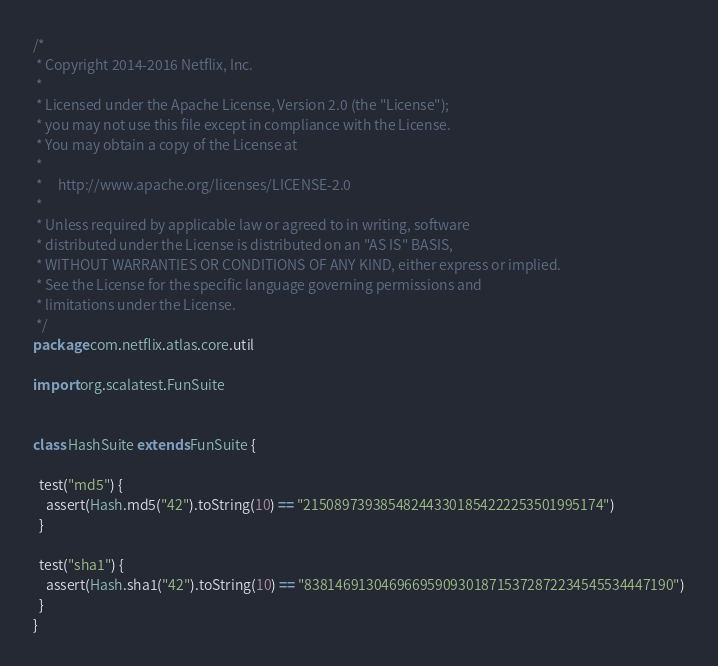<code> <loc_0><loc_0><loc_500><loc_500><_Scala_>/*
 * Copyright 2014-2016 Netflix, Inc.
 *
 * Licensed under the Apache License, Version 2.0 (the "License");
 * you may not use this file except in compliance with the License.
 * You may obtain a copy of the License at
 *
 *     http://www.apache.org/licenses/LICENSE-2.0
 *
 * Unless required by applicable law or agreed to in writing, software
 * distributed under the License is distributed on an "AS IS" BASIS,
 * WITHOUT WARRANTIES OR CONDITIONS OF ANY KIND, either express or implied.
 * See the License for the specific language governing permissions and
 * limitations under the License.
 */
package com.netflix.atlas.core.util

import org.scalatest.FunSuite


class HashSuite extends FunSuite {

  test("md5") {
    assert(Hash.md5("42").toString(10) == "215089739385482443301854222253501995174")
  }

  test("sha1") {
    assert(Hash.sha1("42").toString(10) == "838146913046966959093018715372872234545534447190")
  }
}
</code> 